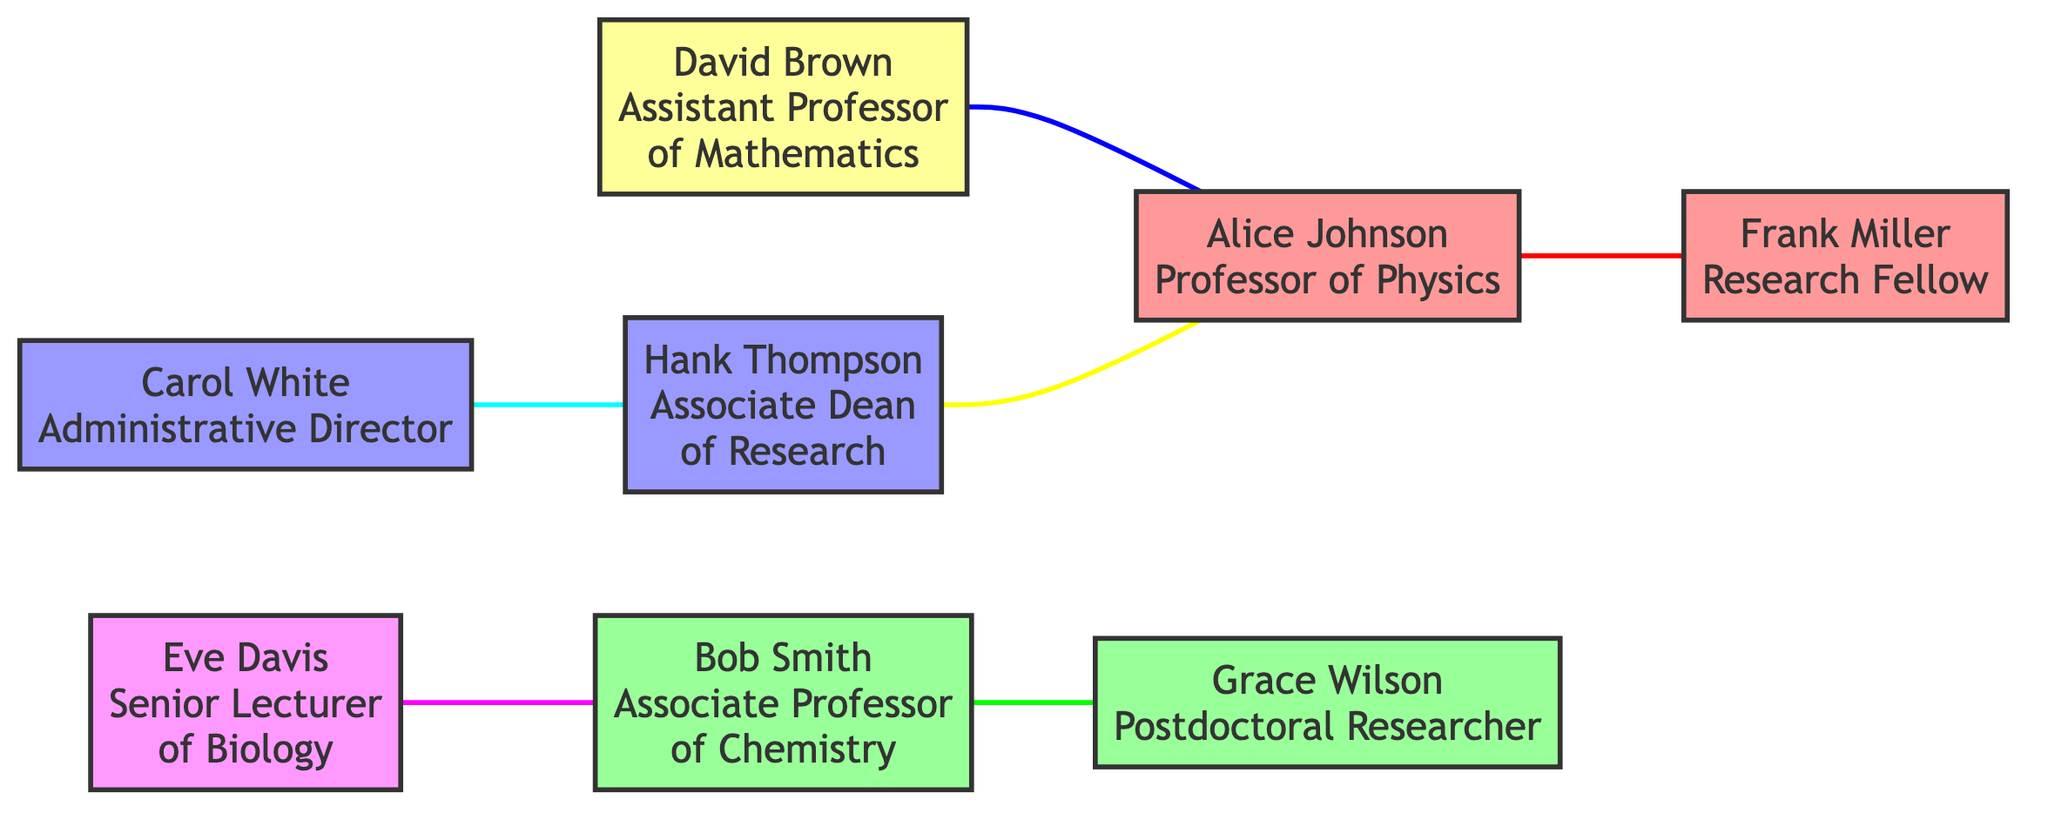What is the total number of nodes in the diagram? The diagram contains 8 unique individuals who are represented as nodes: Alice Johnson, Bob Smith, Carol White, David Brown, Eve Davis, Frank Miller, Grace Wilson, and Hank Thompson. Counting these gives a total of 8 nodes.
Answer: 8 Which department does Alice Johnson belong to? Referring to the node details in the diagram, Alice Johnson is labeled as a Professor of Physics, indicating that her department is Physics.
Answer: Physics Who is represented as a Research Fellow? From the node information, Frank Miller is identified specifically as a Research Fellow. He is also under the Physics department but the title is the relevant information answering the question.
Answer: Frank Miller What type of relationship exists between Eve Davis and Bob Smith? Inspecting the edge connecting Eve Davis and Bob Smith, it is labeled as a "research_project," denoting the nature of their professional relationship.
Answer: research_project How many edges are present in the diagram? The diagram features 6 edges, each representing a professional relationship or collaboration between pairs of nodes. By counting all the connections listed, it totals to 6 edges.
Answer: 6 Is there an interdepartmental grant involving David Brown? Yes, there is an edge linking David Brown to Alice Johnson marked as an "interdepartmental_grant," signifying a grant that involves collaboration between the Mathematics and Physics departments, respectively.
Answer: Yes Which individual has connections to both Administration and Physics? Looking at the connections and nodes, Hank Thompson, the Associate Dean of Research (Administration), is connected to Alice Johnson (Physics) through the research funding committee edge, indicating relationships to both departments.
Answer: Hank Thompson Which node has the role of Administrative Director? By reviewing the nodes in the diagram, Carol White is specifically identified as the Administrative Director, which directly answers the question regarding this role.
Answer: Carol White How many individuals are involved in research-related collaborations? By analyzing the edges, we find that Eve Davis, Bob Smith, David Brown, Alice Johnson, and Frank Miller are involved in various relationships associated with research. Counting these gives a total of 5 individuals engaged in research-related activities.
Answer: 5 